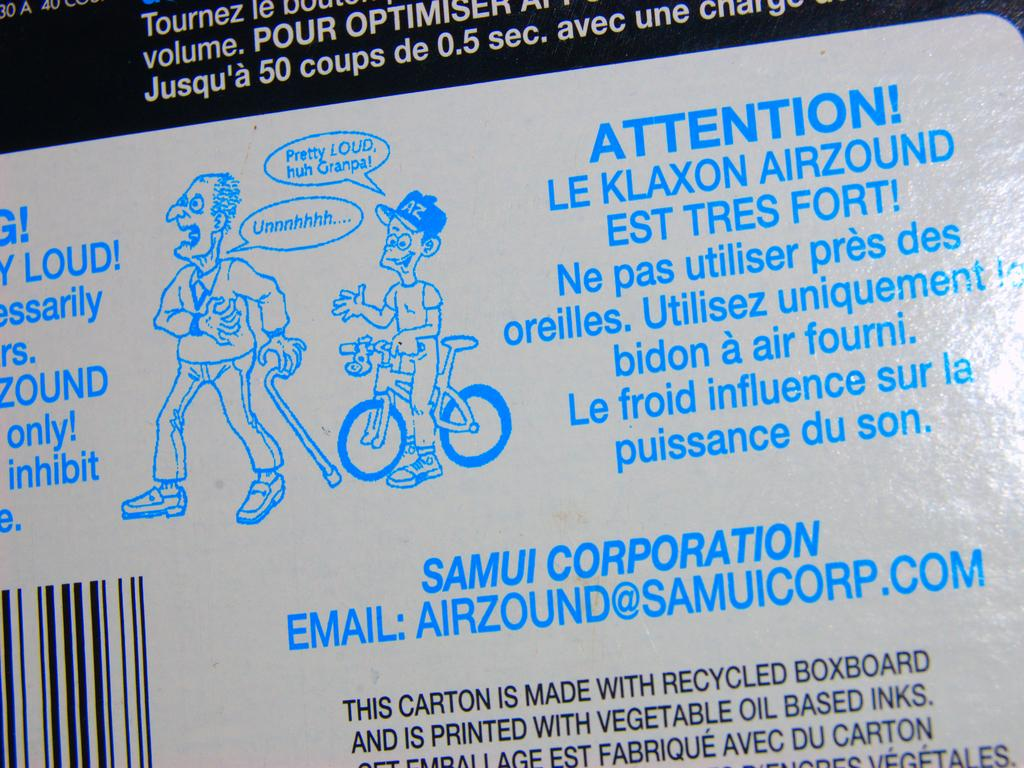What is present on the wall in the image? There is writing on the wall and a painting of a bicycle in the image. Can you describe the painting on the wall? The painting on the wall depicts a bicycle, and there are two people depicted in the painting. What is the purpose of the writing on the wall? The purpose of the writing on the wall is not specified in the image, but it could be a message, quote, or decoration. What scientific experiment is being conducted by the people in the painting? There is no scientific experiment depicted in the painting; it simply shows two people riding a bicycle. 